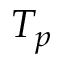Convert formula to latex. <formula><loc_0><loc_0><loc_500><loc_500>T _ { p }</formula> 